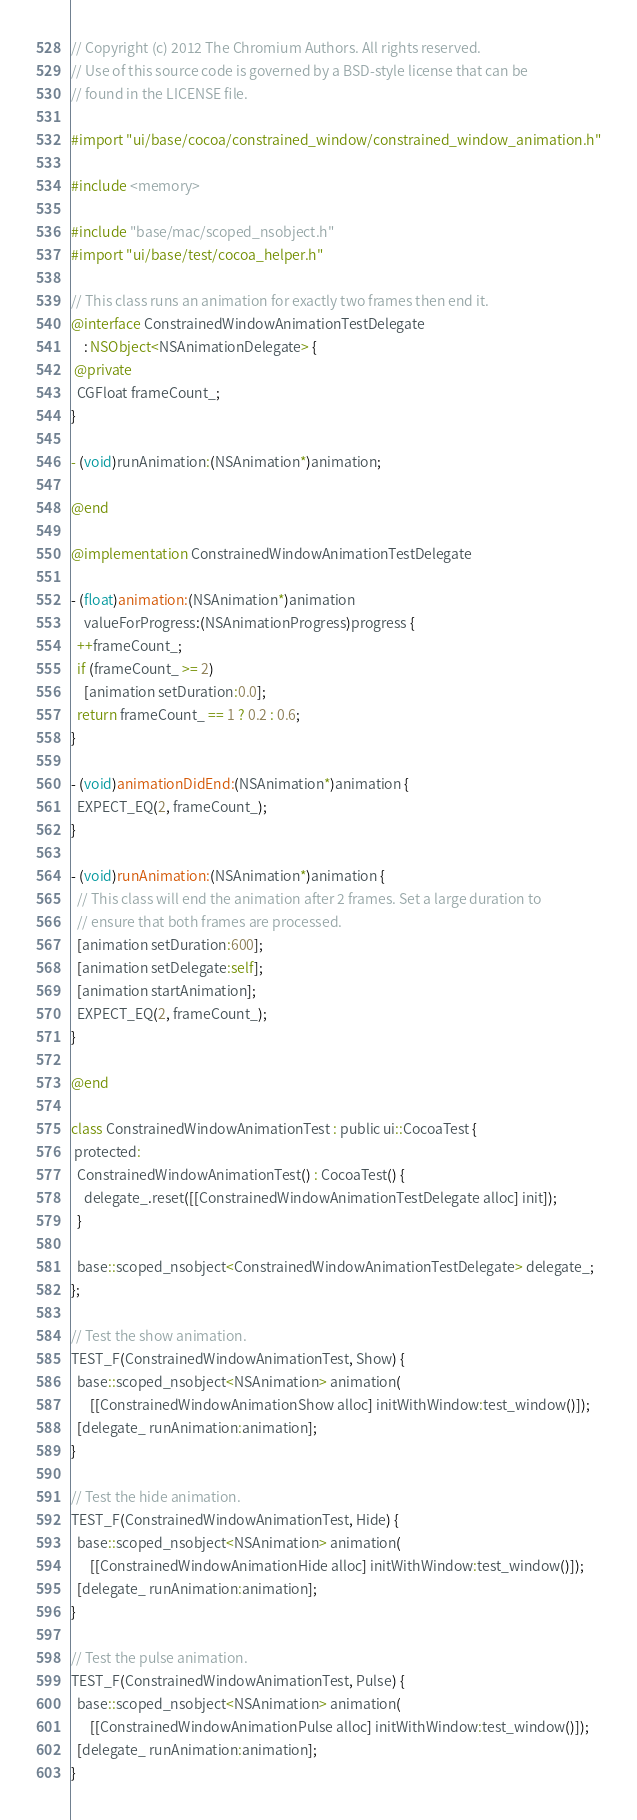<code> <loc_0><loc_0><loc_500><loc_500><_ObjectiveC_>// Copyright (c) 2012 The Chromium Authors. All rights reserved.
// Use of this source code is governed by a BSD-style license that can be
// found in the LICENSE file.

#import "ui/base/cocoa/constrained_window/constrained_window_animation.h"

#include <memory>

#include "base/mac/scoped_nsobject.h"
#import "ui/base/test/cocoa_helper.h"

// This class runs an animation for exactly two frames then end it.
@interface ConstrainedWindowAnimationTestDelegate
    : NSObject<NSAnimationDelegate> {
 @private
  CGFloat frameCount_;
}

- (void)runAnimation:(NSAnimation*)animation;

@end

@implementation ConstrainedWindowAnimationTestDelegate

- (float)animation:(NSAnimation*)animation
    valueForProgress:(NSAnimationProgress)progress {
  ++frameCount_;
  if (frameCount_ >= 2)
    [animation setDuration:0.0];
  return frameCount_ == 1 ? 0.2 : 0.6;
}

- (void)animationDidEnd:(NSAnimation*)animation {
  EXPECT_EQ(2, frameCount_);
}

- (void)runAnimation:(NSAnimation*)animation {
  // This class will end the animation after 2 frames. Set a large duration to
  // ensure that both frames are processed.
  [animation setDuration:600];
  [animation setDelegate:self];
  [animation startAnimation];
  EXPECT_EQ(2, frameCount_);
}

@end

class ConstrainedWindowAnimationTest : public ui::CocoaTest {
 protected:
  ConstrainedWindowAnimationTest() : CocoaTest() {
    delegate_.reset([[ConstrainedWindowAnimationTestDelegate alloc] init]);
  }

  base::scoped_nsobject<ConstrainedWindowAnimationTestDelegate> delegate_;
};

// Test the show animation.
TEST_F(ConstrainedWindowAnimationTest, Show) {
  base::scoped_nsobject<NSAnimation> animation(
      [[ConstrainedWindowAnimationShow alloc] initWithWindow:test_window()]);
  [delegate_ runAnimation:animation];
}

// Test the hide animation.
TEST_F(ConstrainedWindowAnimationTest, Hide) {
  base::scoped_nsobject<NSAnimation> animation(
      [[ConstrainedWindowAnimationHide alloc] initWithWindow:test_window()]);
  [delegate_ runAnimation:animation];
}

// Test the pulse animation.
TEST_F(ConstrainedWindowAnimationTest, Pulse) {
  base::scoped_nsobject<NSAnimation> animation(
      [[ConstrainedWindowAnimationPulse alloc] initWithWindow:test_window()]);
  [delegate_ runAnimation:animation];
}
</code> 